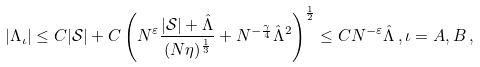<formula> <loc_0><loc_0><loc_500><loc_500>| \Lambda _ { \iota } | \leq C | \mathcal { S } | + C \left ( N ^ { \varepsilon } \frac { | \mathcal { S } | + \hat { \Lambda } } { ( N \eta ) ^ { \frac { 1 } { 3 } } } + N ^ { - \frac { \gamma } { 4 } } \hat { \Lambda } ^ { 2 } \right ) ^ { \frac { 1 } { 2 } } \leq C N ^ { - \varepsilon } \hat { \Lambda } \, , \iota = A , B \, ,</formula> 